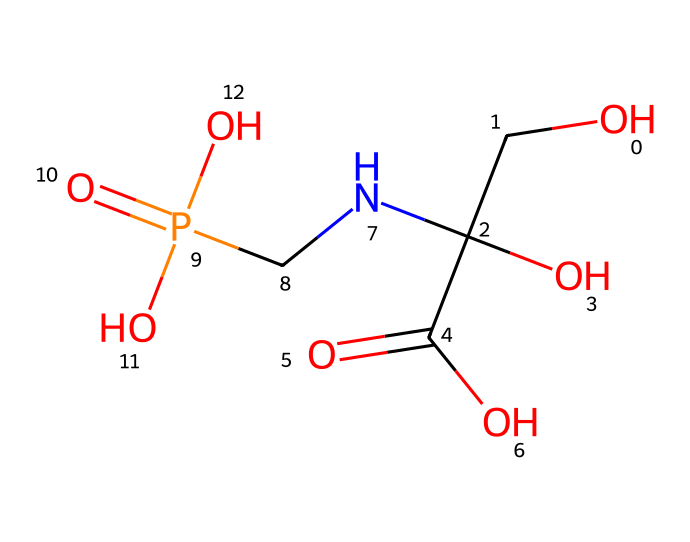What is the total number of carbon atoms in glyphosate? By analyzing the SMILES representation, we can identify the carbon atoms. The main chain and branches show a total of three carbon atoms (C).
Answer: three How many nitrogens are present in the glyphosate structure? In the SMILES, we observe "N" indicating the presence of one nitrogen atom in the structure.
Answer: one What functional group is indicated by "C(=O)O" in glyphosate? The notation "C(=O)O" represents a carboxylic acid functional group, characterized by a carbonyl (C=O) bonded to a hydroxyl (O).
Answer: carboxylic acid What is the overall charge of glyphosate? The presence of various functional groups such as phosphonic acid (P(=O)(O)O) leads to the presence of acidic hydrogen atoms, suggesting the overall molecule can stabilize a negative charge.
Answer: negative How many oxygen atoms does glyphosate contain? Counting the "O" symbols in the SMILES representation, we find four oxygen atoms present in the glyphosate structure.
Answer: four Which part of the glyphosate structure allows it to inhibit the shikimic acid pathway? The presence of the phosphonic acid (P(=O)(O)O) in the structure is crucial because it mimics the structure of phosphoenolpyruvate, enabling glyphosate to interfere with the shikimic acid pathway.
Answer: phosphonic acid What type of herbicide is glyphosate classified as based on its mechanism of action? Glyphosate is classified as a systemic herbicide because it is absorbed through the plant leaves and translocated to other parts of the plant affecting its growth.
Answer: systemic 